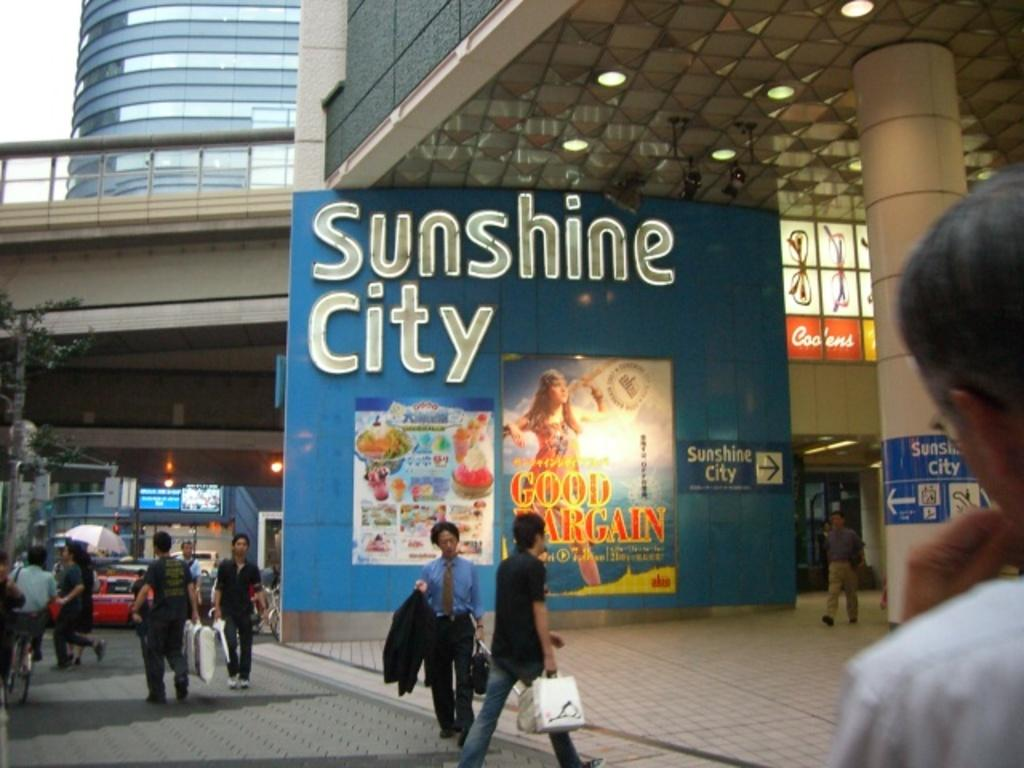<image>
Provide a brief description of the given image. A large sign on the side of a building proclaims Sunshine City. 